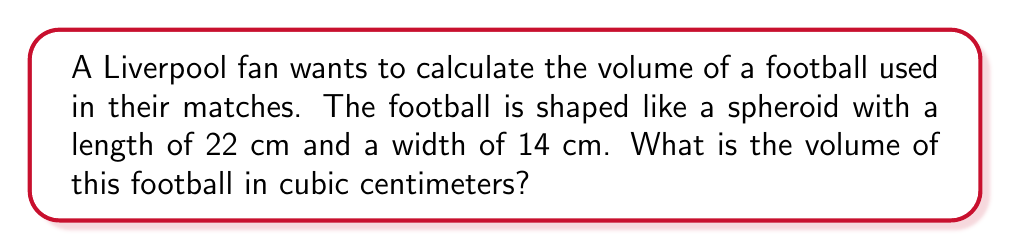Help me with this question. To calculate the volume of a football-shaped spheroid, we'll use the formula for the volume of a prolate spheroid:

$$V = \frac{4}{3}\pi a b^2$$

Where:
$a$ is half the length of the longest axis
$b$ is half the length of the shorter axis

Step 1: Determine $a$ and $b$
$a = 22 \text{ cm} \div 2 = 11 \text{ cm}$
$b = 14 \text{ cm} \div 2 = 7 \text{ cm}$

Step 2: Substitute these values into the formula
$$V = \frac{4}{3}\pi (11)(7^2)$$

Step 3: Simplify
$$V = \frac{4}{3}\pi (11)(49)$$
$$V = \frac{4}{3}\pi (539)$$

Step 4: Calculate the final result
$$V \approx 2,265.73 \text{ cm}^3$$
Answer: $2,265.73 \text{ cm}^3$ 